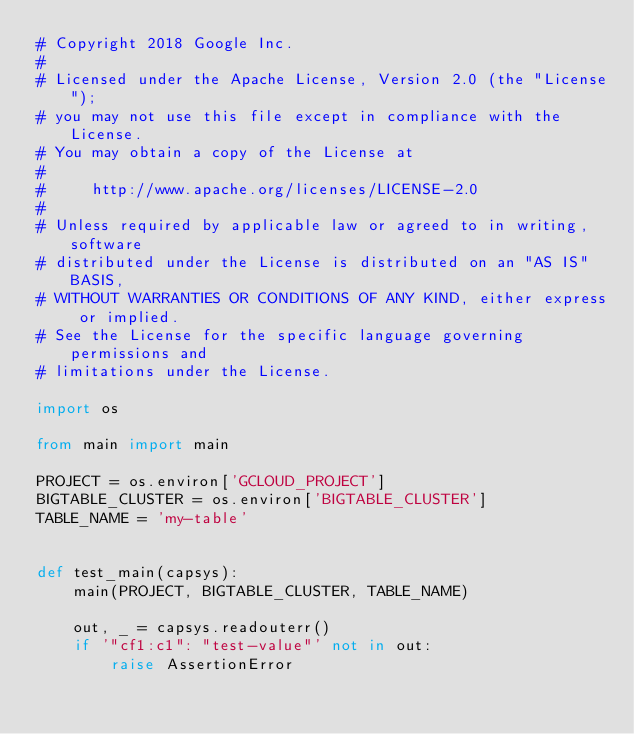<code> <loc_0><loc_0><loc_500><loc_500><_Python_># Copyright 2018 Google Inc.
#
# Licensed under the Apache License, Version 2.0 (the "License");
# you may not use this file except in compliance with the License.
# You may obtain a copy of the License at
#
#     http://www.apache.org/licenses/LICENSE-2.0
#
# Unless required by applicable law or agreed to in writing, software
# distributed under the License is distributed on an "AS IS" BASIS,
# WITHOUT WARRANTIES OR CONDITIONS OF ANY KIND, either express or implied.
# See the License for the specific language governing permissions and
# limitations under the License.

import os

from main import main

PROJECT = os.environ['GCLOUD_PROJECT']
BIGTABLE_CLUSTER = os.environ['BIGTABLE_CLUSTER']
TABLE_NAME = 'my-table'


def test_main(capsys):
    main(PROJECT, BIGTABLE_CLUSTER, TABLE_NAME)

    out, _ = capsys.readouterr()
    if '"cf1:c1": "test-value"' not in out:
        raise AssertionError
</code> 